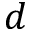Convert formula to latex. <formula><loc_0><loc_0><loc_500><loc_500>d</formula> 